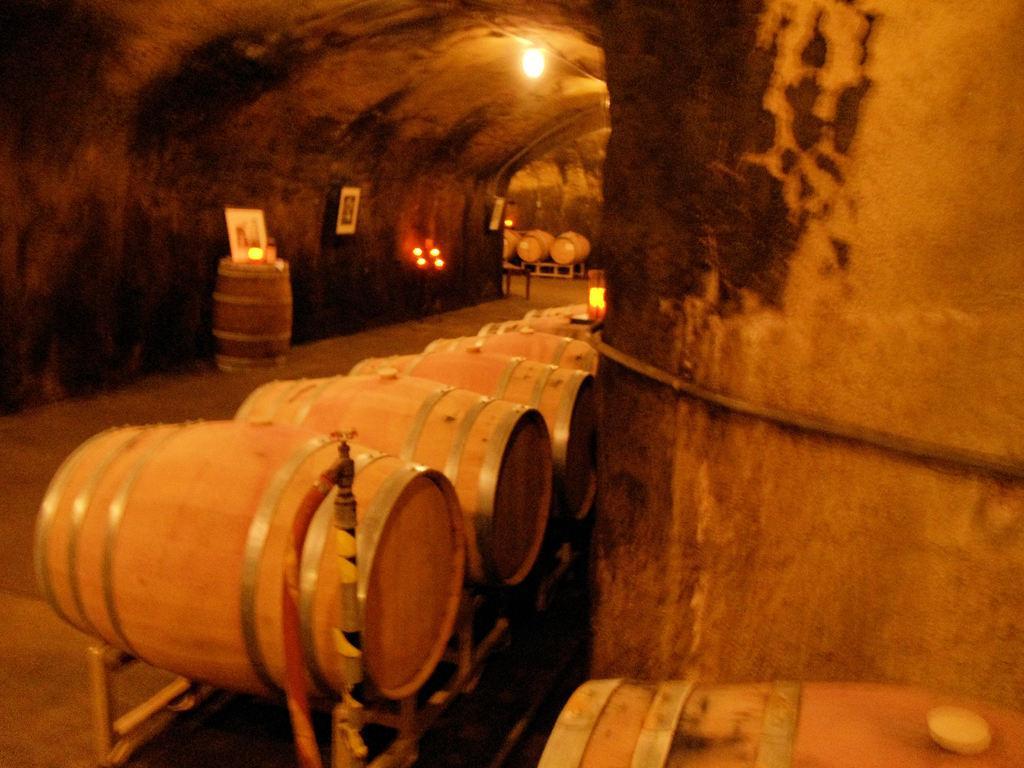In one or two sentences, can you explain what this image depicts? In this picture we can see barrels, walls, lights, frame, floor and some objects. 